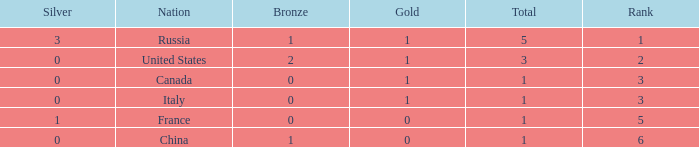Name the total number of ranks when total is less than 1 0.0. 